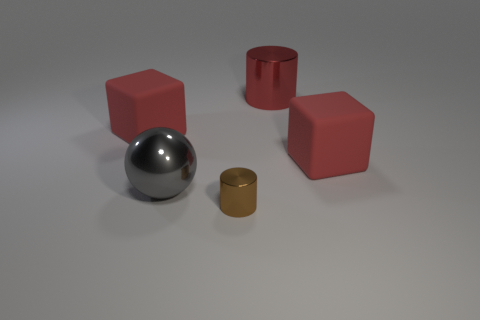There is a metallic object that is behind the red thing in front of the red cube that is left of the gray object; what is its shape?
Keep it short and to the point. Cylinder. Is the number of matte things that are left of the big gray object greater than the number of large blue metal things?
Make the answer very short. Yes. There is a tiny object; is its shape the same as the shiny thing that is behind the big gray metallic sphere?
Your response must be concise. Yes. There is a red matte object that is left of the large block to the right of the tiny brown object; what number of large red things are behind it?
Give a very brief answer. 1. There is another metal thing that is the same size as the gray metallic thing; what is its color?
Your response must be concise. Red. There is a cylinder that is in front of the red block that is to the right of the small brown cylinder; what size is it?
Your response must be concise. Small. How many other objects are there of the same size as the gray thing?
Make the answer very short. 3. What number of big gray metal balls are there?
Keep it short and to the point. 1. Is the ball the same size as the red cylinder?
Ensure brevity in your answer.  Yes. How many other objects are the same shape as the brown thing?
Keep it short and to the point. 1. 